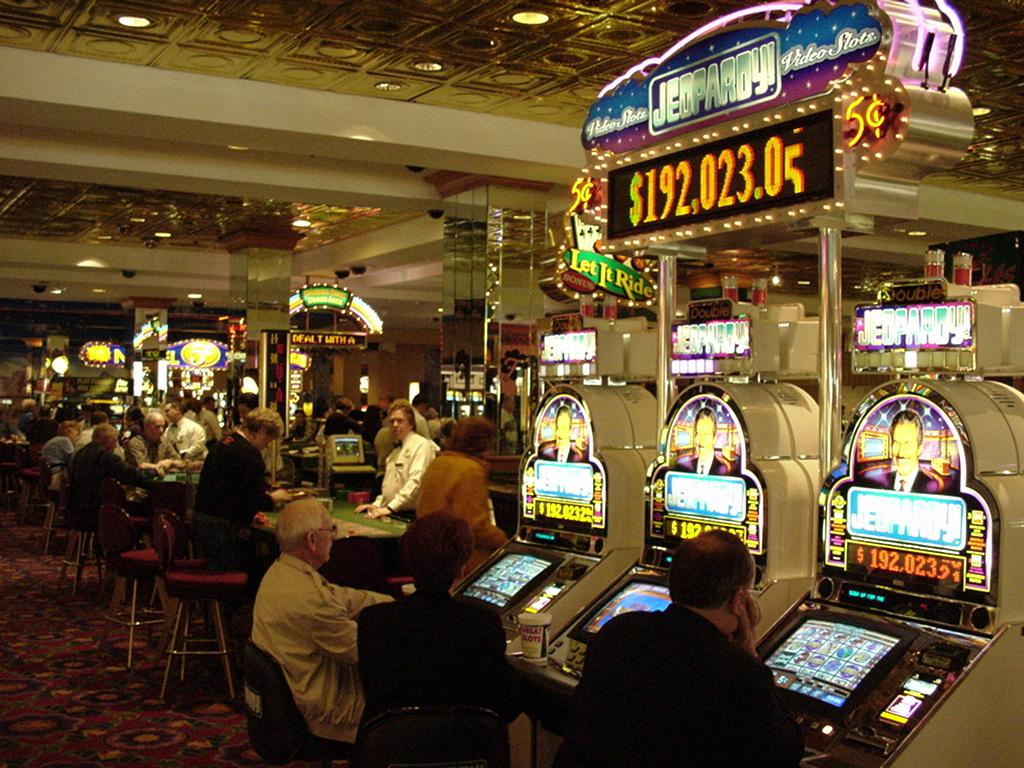What type of establishment is shown in the image? The image depicts a casino. What are the people in the casino doing? There are people seated and standing in the casino. What types of gaming equipment are present in the casino? There are machines and tables in the casino. What can be seen on the roof of the casino? There are lights on the roof of the casino. Where is the vase located in the image? There is no vase present in the image. What type of pipe can be seen in the image? There is no pipe present in the image. 